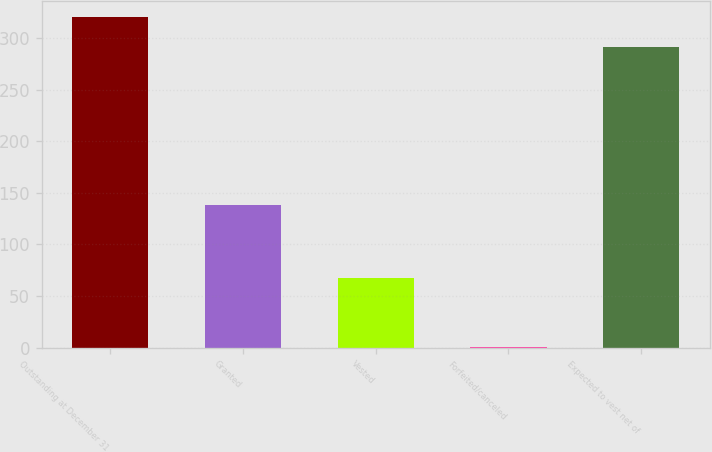<chart> <loc_0><loc_0><loc_500><loc_500><bar_chart><fcel>Outstanding at December 31<fcel>Granted<fcel>Vested<fcel>Forfeited/canceled<fcel>Expected to vest net of<nl><fcel>320.3<fcel>138<fcel>68<fcel>1<fcel>291<nl></chart> 